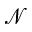Convert formula to latex. <formula><loc_0><loc_0><loc_500><loc_500>\mathcal { N }</formula> 